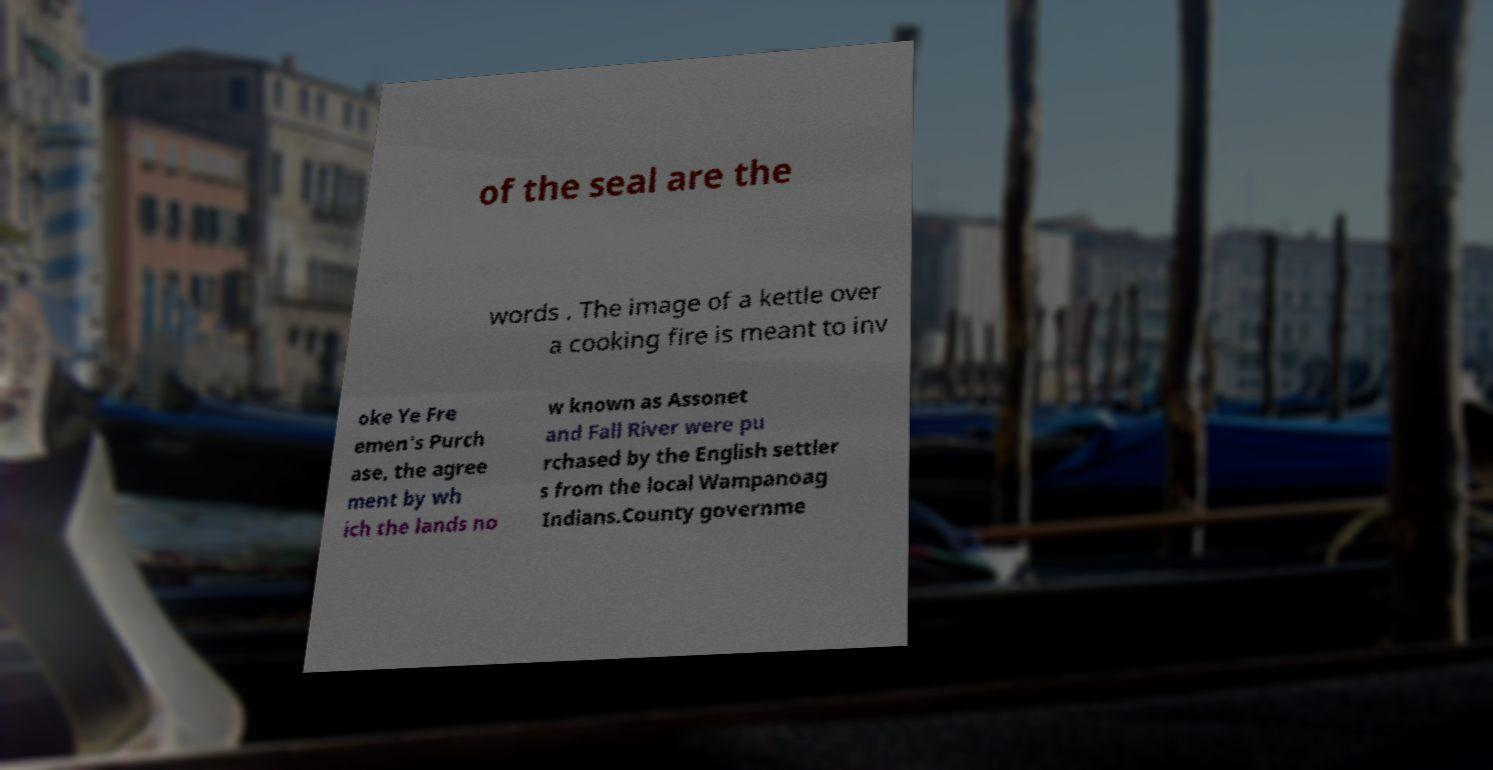What messages or text are displayed in this image? I need them in a readable, typed format. of the seal are the words . The image of a kettle over a cooking fire is meant to inv oke Ye Fre emen's Purch ase, the agree ment by wh ich the lands no w known as Assonet and Fall River were pu rchased by the English settler s from the local Wampanoag Indians.County governme 